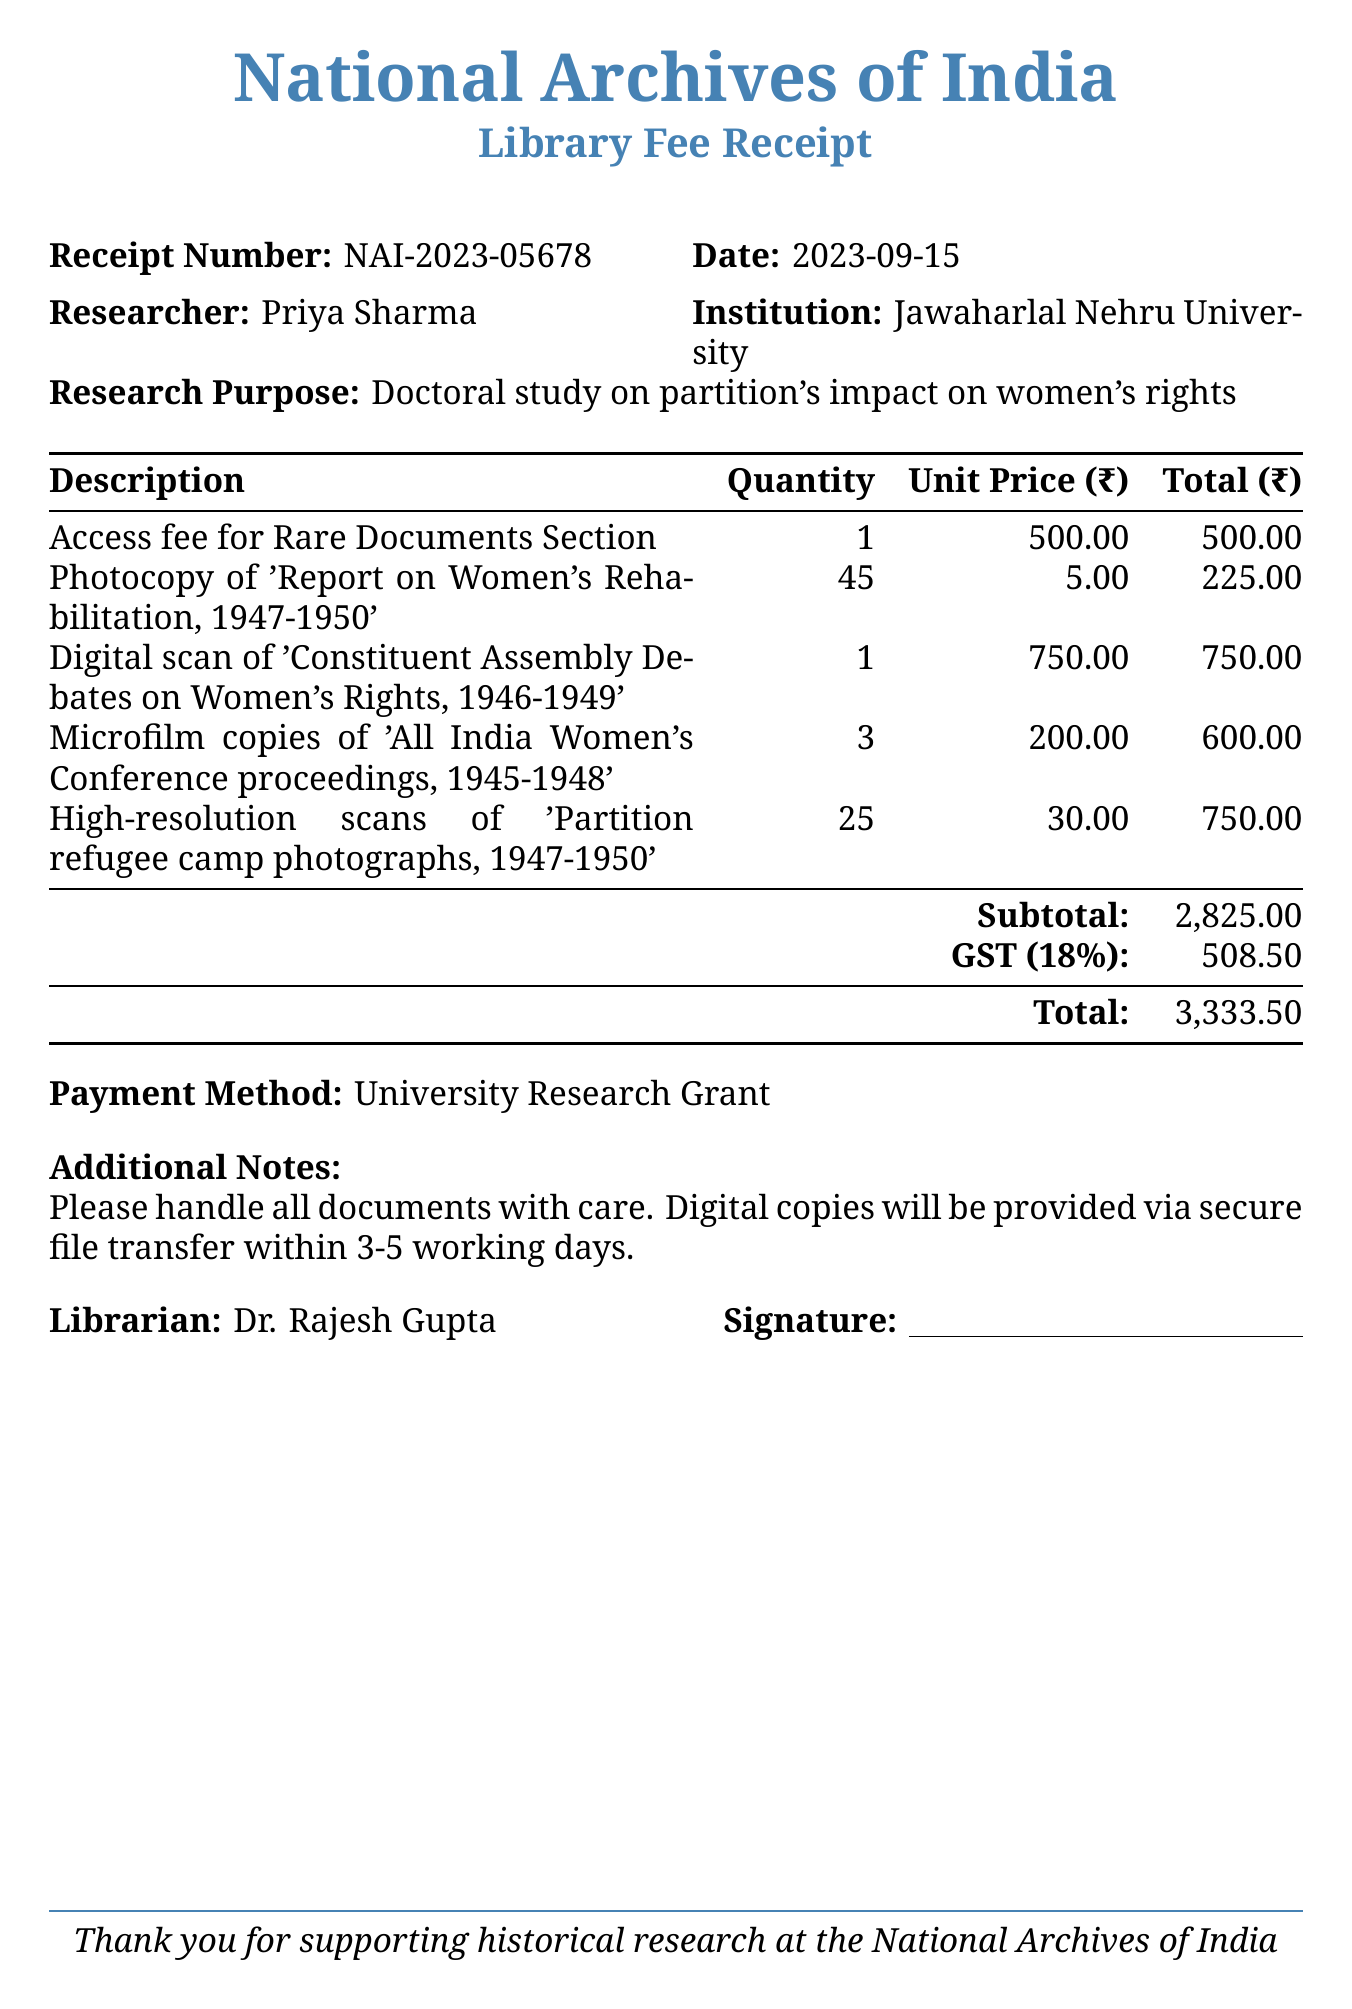What is the receipt number? The receipt number is a unique identifier for the transaction recorded in the document.
Answer: NAI-2023-05678 What is the total amount due? The total amount due is calculated by adding the subtotal and GST in the document.
Answer: 3333.5 Who is the researcher? The researcher is the individual who requested the services and is noted in the document.
Answer: Priya Sharma What is the access fee for the Rare Documents Section? The access fee is specified as a separate charge in the itemized list of fees.
Answer: 500 How many items were photocopied? The quantity of items photocopied is mentioned next to the corresponding description in the document.
Answer: 45 What is the payment method used? The payment method is specified towards the end of the document, indicating how the fees were settled.
Answer: University Research Grant What is the total GST charged? The GST amount is clearly stated in the document as part of the total calculation.
Answer: 508.5 Who is the librarian? The librarian's name is included in the document, indicating the person responsible for the transaction.
Answer: Dr. Rajesh Gupta What does the additional note mention about digital copies? The additional note provides specific instructions or information regarding the handling of documents and delivery of digital copies.
Answer: Digital copies will be provided via secure file transfer within 3-5 working days 